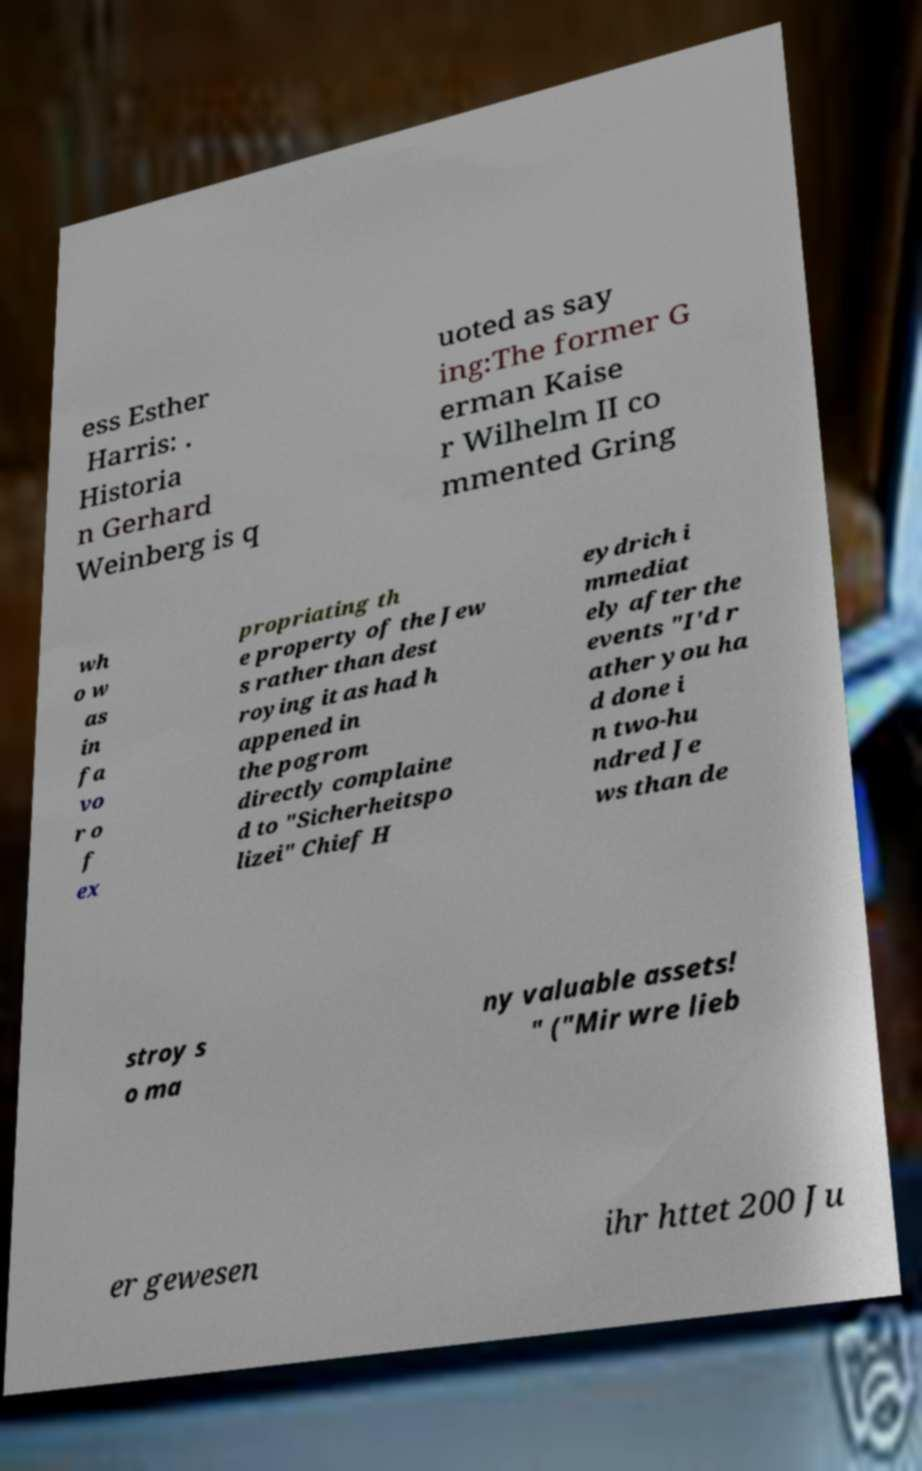What messages or text are displayed in this image? I need them in a readable, typed format. ess Esther Harris: . Historia n Gerhard Weinberg is q uoted as say ing:The former G erman Kaise r Wilhelm II co mmented Gring wh o w as in fa vo r o f ex propriating th e property of the Jew s rather than dest roying it as had h appened in the pogrom directly complaine d to "Sicherheitspo lizei" Chief H eydrich i mmediat ely after the events "I'd r ather you ha d done i n two-hu ndred Je ws than de stroy s o ma ny valuable assets! " ("Mir wre lieb er gewesen ihr httet 200 Ju 